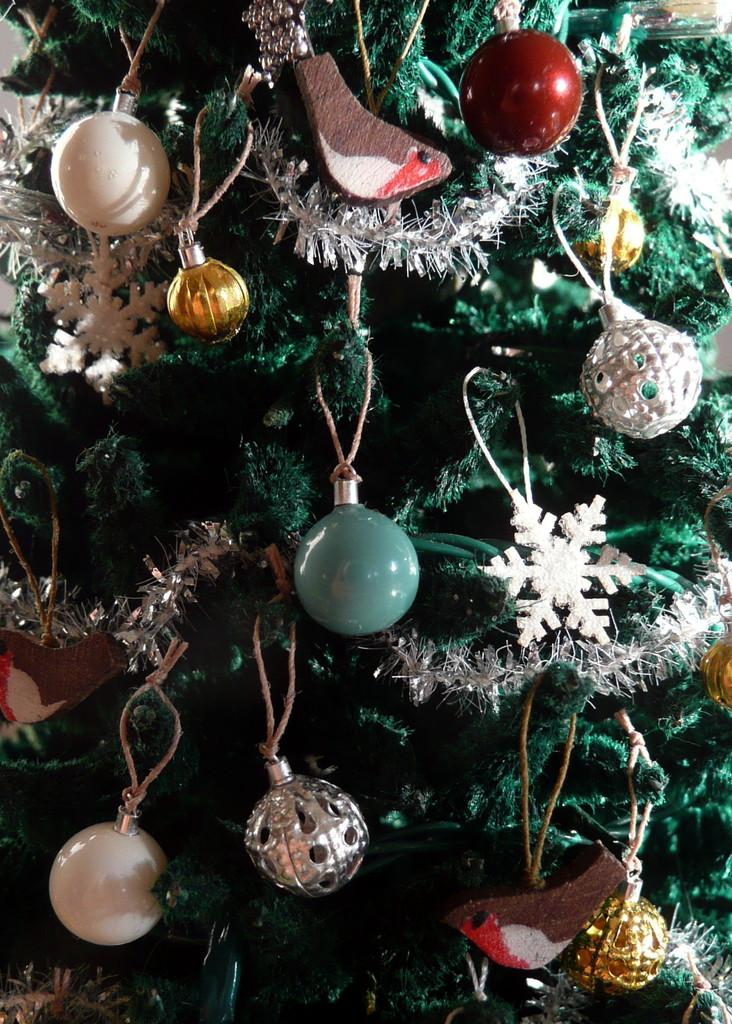What is the main subject of the picture? The main subject of the picture is a Christmas tree. What type of decorations can be seen on the Christmas tree? There are decorative balls on the Christmas tree. How many geese are flying around the Christmas tree in the image? There are no geese present in the image; it only features a Christmas tree with decorative balls. What type of locket can be seen hanging from the Christmas tree? There is no locket present on the Christmas tree in the image. 